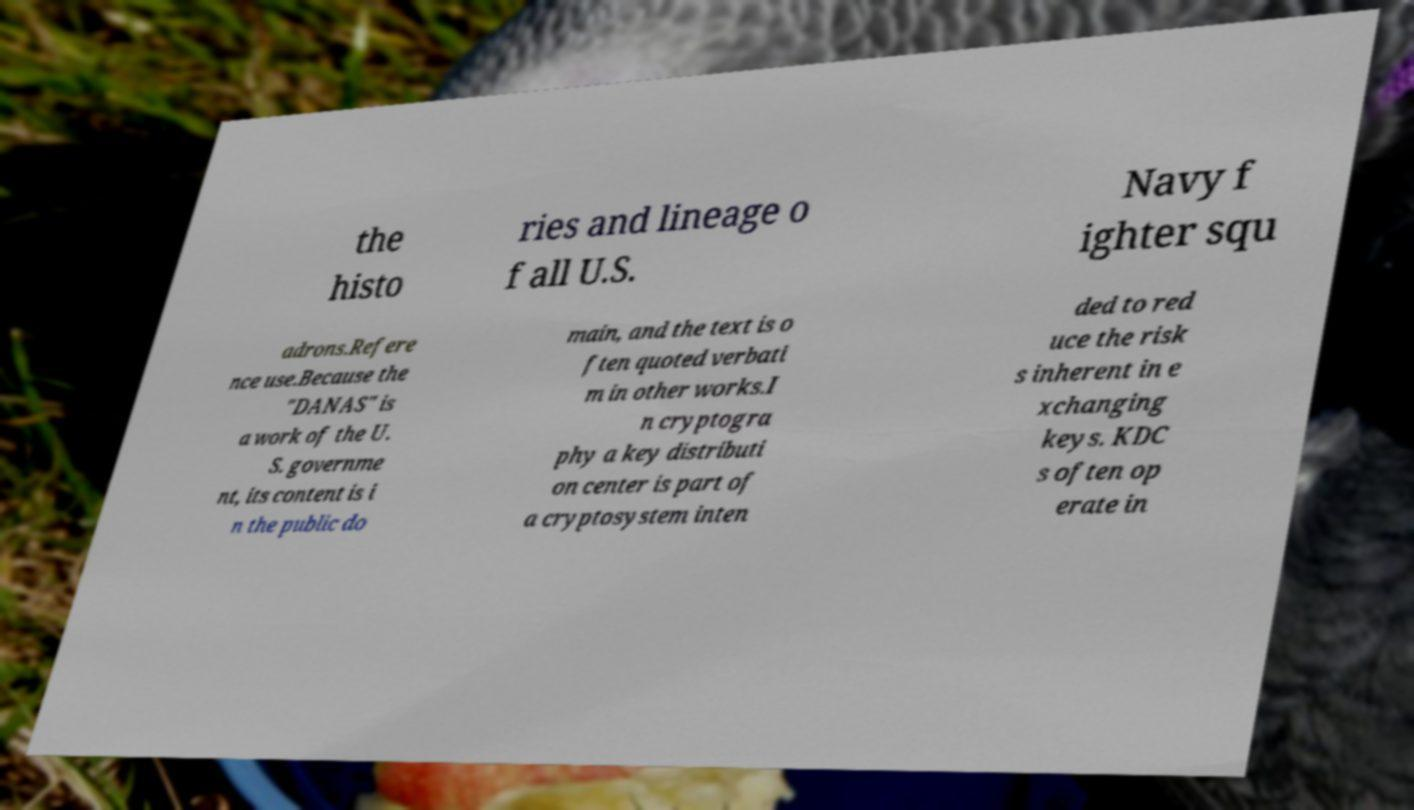What is the subject of the document shown in this image? The document appears to discuss subjects related to the U.S. Navy, specifically the histories and lineages of fighter squadrons. It also makes reference to public domain content, suggesting the information is likely well-documented and freely accessible for use in research or other works. Can you tell me more about the U.S. Navy's fighter squadrons? U.S. Navy fighter squadrons are integral components of naval aviation, renowned for their advanced aircraft and skilled pilots. These squadrons have significant histories dating back to the early 20th century and have been involved in various conflicts, providing air support, reconnaissance, and engaging in aerial combat. Each squadron has a unique lineage that comprises its formation, deployment history, aircraft flown, and significant events throughout its service. 